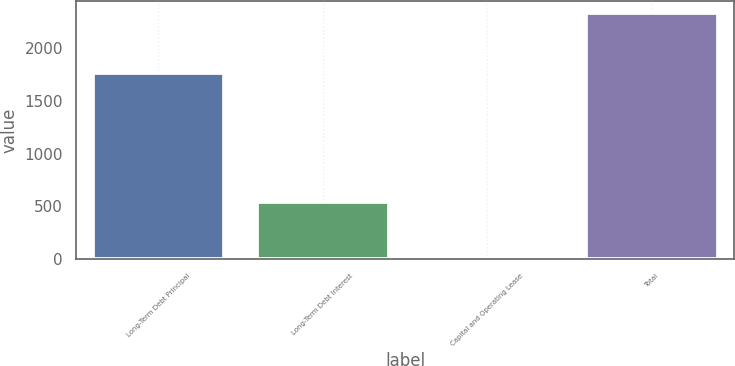Convert chart. <chart><loc_0><loc_0><loc_500><loc_500><bar_chart><fcel>Long-Term Debt Principal<fcel>Long-Term Debt Interest<fcel>Capital and Operating Lease<fcel>Total<nl><fcel>1766<fcel>546<fcel>14<fcel>2326<nl></chart> 